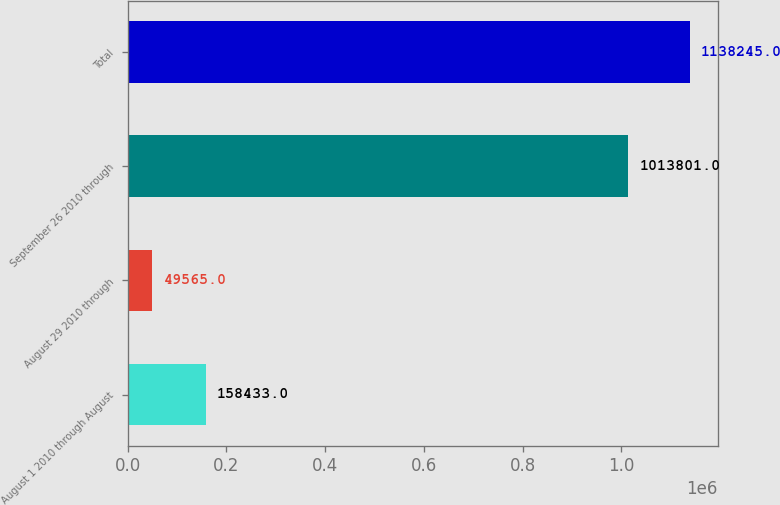<chart> <loc_0><loc_0><loc_500><loc_500><bar_chart><fcel>August 1 2010 through August<fcel>August 29 2010 through<fcel>September 26 2010 through<fcel>Total<nl><fcel>158433<fcel>49565<fcel>1.0138e+06<fcel>1.13824e+06<nl></chart> 